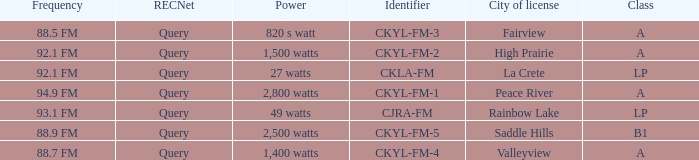What is the city of license that has a 1,400 watts power Valleyview. 